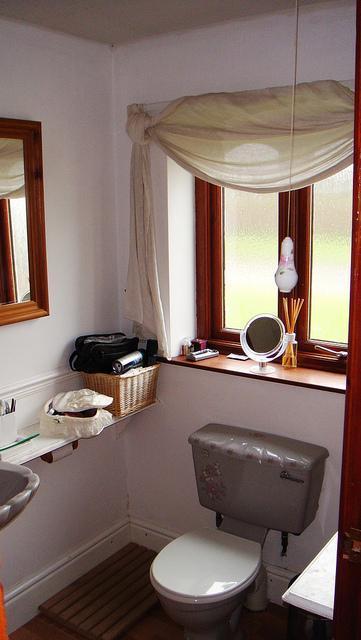How many people are wearing orange shirts?
Give a very brief answer. 0. 